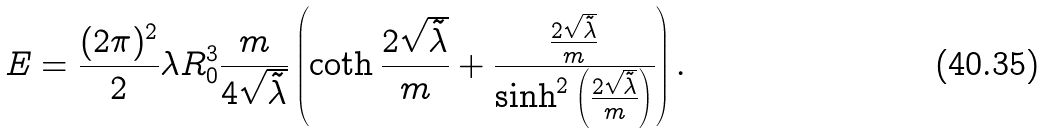Convert formula to latex. <formula><loc_0><loc_0><loc_500><loc_500>E = \frac { ( 2 \pi ) ^ { 2 } } { 2 } \lambda R _ { 0 } ^ { 3 } \frac { m } { 4 \sqrt { \tilde { \lambda } } } \left ( \coth \frac { 2 \sqrt { \tilde { \lambda } } } { m } + \frac { \frac { 2 \sqrt { \tilde { \lambda } } } { m } } { \sinh ^ { 2 } \left ( \frac { 2 \sqrt { \tilde { \lambda } } } { m } \right ) } \right ) .</formula> 